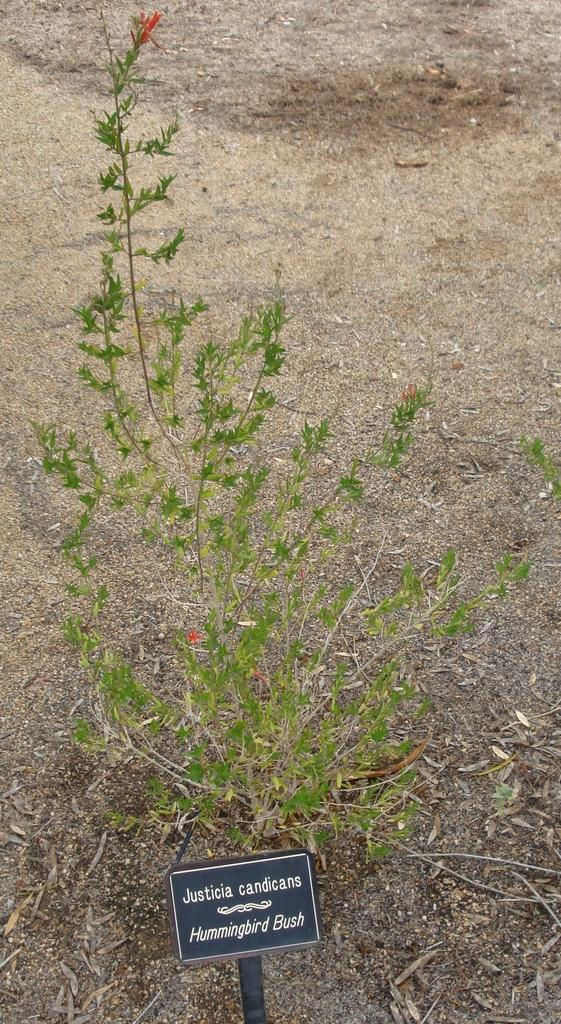What is the color of the board in the image? The board in the image is black. What can be seen on the board? Something is written on the board. Can you describe the celestial object visible in the image? There is a planet visible in the image. What type of weather can be seen in the image? There is no weather visible in the image; it is a black color board with writing and a planet. Can you tell me how many graves are present in the image? There is no cemetery or graves present in the image; it features a black color board with writing and a planet. 